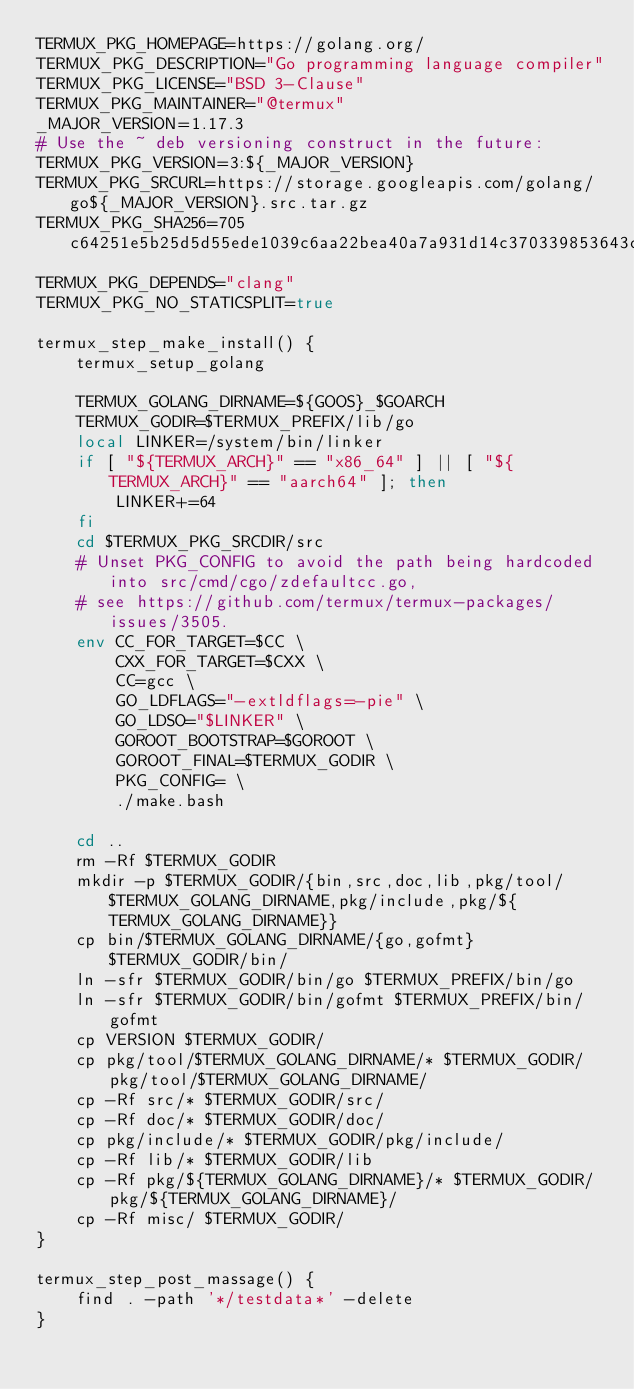<code> <loc_0><loc_0><loc_500><loc_500><_Bash_>TERMUX_PKG_HOMEPAGE=https://golang.org/
TERMUX_PKG_DESCRIPTION="Go programming language compiler"
TERMUX_PKG_LICENSE="BSD 3-Clause"
TERMUX_PKG_MAINTAINER="@termux"
_MAJOR_VERSION=1.17.3
# Use the ~ deb versioning construct in the future:
TERMUX_PKG_VERSION=3:${_MAJOR_VERSION}
TERMUX_PKG_SRCURL=https://storage.googleapis.com/golang/go${_MAJOR_VERSION}.src.tar.gz
TERMUX_PKG_SHA256=705c64251e5b25d5d55ede1039c6aa22bea40a7a931d14c370339853643c3df0
TERMUX_PKG_DEPENDS="clang"
TERMUX_PKG_NO_STATICSPLIT=true

termux_step_make_install() {
	termux_setup_golang

	TERMUX_GOLANG_DIRNAME=${GOOS}_$GOARCH
	TERMUX_GODIR=$TERMUX_PREFIX/lib/go
	local LINKER=/system/bin/linker
	if [ "${TERMUX_ARCH}" == "x86_64" ] || [ "${TERMUX_ARCH}" == "aarch64" ]; then
		LINKER+=64
	fi
	cd $TERMUX_PKG_SRCDIR/src
	# Unset PKG_CONFIG to avoid the path being hardcoded into src/cmd/cgo/zdefaultcc.go,
	# see https://github.com/termux/termux-packages/issues/3505.
	env CC_FOR_TARGET=$CC \
	    CXX_FOR_TARGET=$CXX \
	    CC=gcc \
	    GO_LDFLAGS="-extldflags=-pie" \
	    GO_LDSO="$LINKER" \
	    GOROOT_BOOTSTRAP=$GOROOT \
	    GOROOT_FINAL=$TERMUX_GODIR \
	    PKG_CONFIG= \
	    ./make.bash

	cd ..
	rm -Rf $TERMUX_GODIR
	mkdir -p $TERMUX_GODIR/{bin,src,doc,lib,pkg/tool/$TERMUX_GOLANG_DIRNAME,pkg/include,pkg/${TERMUX_GOLANG_DIRNAME}}
	cp bin/$TERMUX_GOLANG_DIRNAME/{go,gofmt} $TERMUX_GODIR/bin/
	ln -sfr $TERMUX_GODIR/bin/go $TERMUX_PREFIX/bin/go
	ln -sfr $TERMUX_GODIR/bin/gofmt $TERMUX_PREFIX/bin/gofmt
	cp VERSION $TERMUX_GODIR/
	cp pkg/tool/$TERMUX_GOLANG_DIRNAME/* $TERMUX_GODIR/pkg/tool/$TERMUX_GOLANG_DIRNAME/
	cp -Rf src/* $TERMUX_GODIR/src/
	cp -Rf doc/* $TERMUX_GODIR/doc/
	cp pkg/include/* $TERMUX_GODIR/pkg/include/
	cp -Rf lib/* $TERMUX_GODIR/lib
	cp -Rf pkg/${TERMUX_GOLANG_DIRNAME}/* $TERMUX_GODIR/pkg/${TERMUX_GOLANG_DIRNAME}/
	cp -Rf misc/ $TERMUX_GODIR/
}

termux_step_post_massage() {
	find . -path '*/testdata*' -delete
}
</code> 